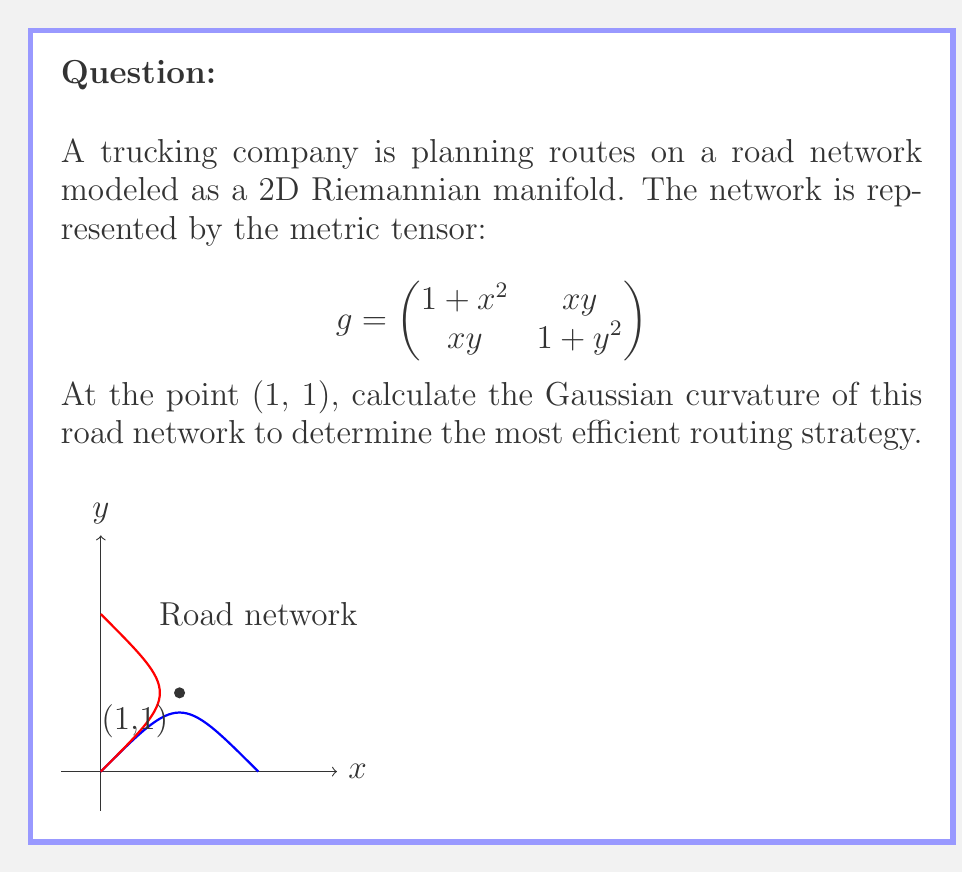Can you answer this question? To calculate the Gaussian curvature of a 2D Riemannian manifold, we need to follow these steps:

1) First, we need to calculate the components of the Riemann curvature tensor. In 2D, there's only one independent component, $R_{1212}$.

2) The formula for $R_{1212}$ is:

   $$R_{1212} = \frac{1}{2}(\partial_1\partial_1 g_{22} + \partial_2\partial_2 g_{11} - 2\partial_1\partial_2 g_{12}) + g^{ab}(\Gamma_{a12}\Gamma_{b21} - \Gamma_{a11}\Gamma_{b22})$$

   where $\Gamma_{ijk}$ are the Christoffel symbols.

3) Calculate the partial derivatives:
   $\partial_1\partial_1 g_{22} = 0$
   $\partial_2\partial_2 g_{11} = 0$
   $\partial_1\partial_2 g_{12} = 1$

4) Calculate the Christoffel symbols:
   $\Gamma_{111} = \frac{x}{1+x^2}$, $\Gamma_{112} = \Gamma_{121} = \frac{y}{2(1+x^2)}$
   $\Gamma_{122} = \frac{x}{1+y^2}$, $\Gamma_{222} = \frac{y}{1+y^2}$
   $\Gamma_{211} = -\frac{x}{1+y^2}$, $\Gamma_{212} = \Gamma_{221} = \frac{y}{2(1+y^2)}$

5) Calculate the inverse metric:
   $$g^{-1} = \frac{1}{(1+x^2)(1+y^2)-x^2y^2} \begin{pmatrix}
   1+y^2 & -xy \\
   -xy & 1+x^2
   \end{pmatrix}$$

6) Substitute all these into the formula for $R_{1212}$ and evaluate at (1,1):

   $$R_{1212}|_{(1,1)} = -1 + \frac{4}{9}(\frac{1}{4} + \frac{1}{4} - \frac{1}{2} - \frac{1}{2}) = -1$$

7) The Gaussian curvature K is given by:
   $$K = \frac{R_{1212}}{\det(g)}$$

8) At (1,1), $\det(g) = 4$, so:
   $$K = -\frac{1}{4}$$
Answer: $K = -\frac{1}{4}$ 